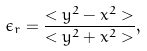Convert formula to latex. <formula><loc_0><loc_0><loc_500><loc_500>\epsilon _ { r } = \frac { < y ^ { 2 } - x ^ { 2 } > } { < y ^ { 2 } + x ^ { 2 } > } ,</formula> 